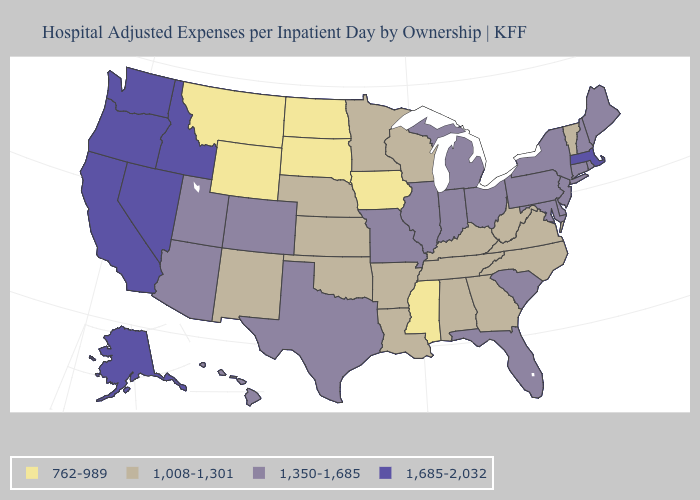What is the value of Arizona?
Answer briefly. 1,350-1,685. Name the states that have a value in the range 1,685-2,032?
Be succinct. Alaska, California, Idaho, Massachusetts, Nevada, Oregon, Washington. Name the states that have a value in the range 1,350-1,685?
Quick response, please. Arizona, Colorado, Connecticut, Delaware, Florida, Hawaii, Illinois, Indiana, Maine, Maryland, Michigan, Missouri, New Hampshire, New Jersey, New York, Ohio, Pennsylvania, Rhode Island, South Carolina, Texas, Utah. What is the value of Wyoming?
Answer briefly. 762-989. What is the value of Alaska?
Short answer required. 1,685-2,032. Does the first symbol in the legend represent the smallest category?
Give a very brief answer. Yes. Name the states that have a value in the range 1,008-1,301?
Concise answer only. Alabama, Arkansas, Georgia, Kansas, Kentucky, Louisiana, Minnesota, Nebraska, New Mexico, North Carolina, Oklahoma, Tennessee, Vermont, Virginia, West Virginia, Wisconsin. Among the states that border Minnesota , which have the lowest value?
Give a very brief answer. Iowa, North Dakota, South Dakota. Does Maine have the same value as Alaska?
Short answer required. No. What is the lowest value in the Northeast?
Short answer required. 1,008-1,301. Does Maryland have the highest value in the South?
Concise answer only. Yes. Does the map have missing data?
Write a very short answer. No. Does the map have missing data?
Keep it brief. No. Name the states that have a value in the range 762-989?
Short answer required. Iowa, Mississippi, Montana, North Dakota, South Dakota, Wyoming. What is the highest value in states that border Wisconsin?
Answer briefly. 1,350-1,685. 